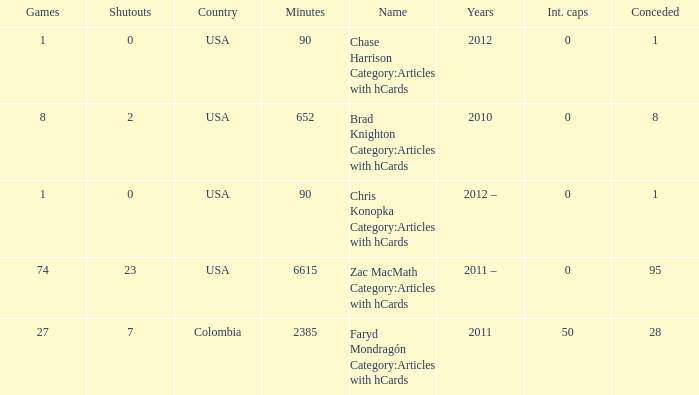What is the lowest overall amount of shutouts? 0.0. 